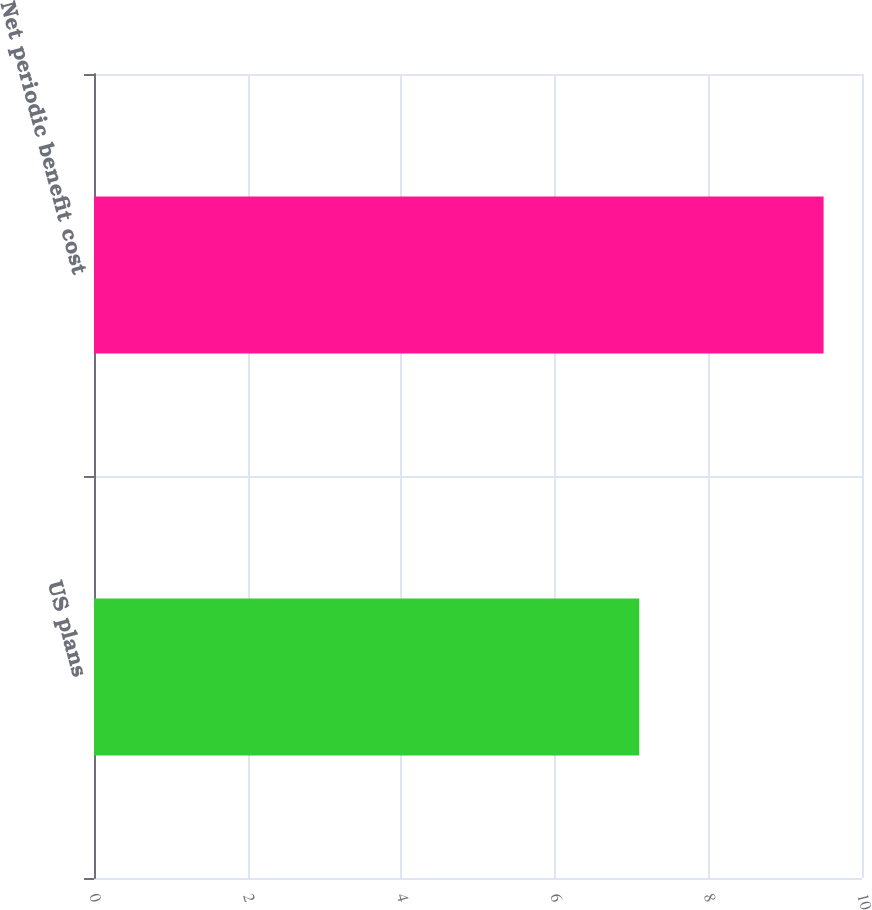Convert chart. <chart><loc_0><loc_0><loc_500><loc_500><bar_chart><fcel>US plans<fcel>Net periodic benefit cost<nl><fcel>7.1<fcel>9.5<nl></chart> 